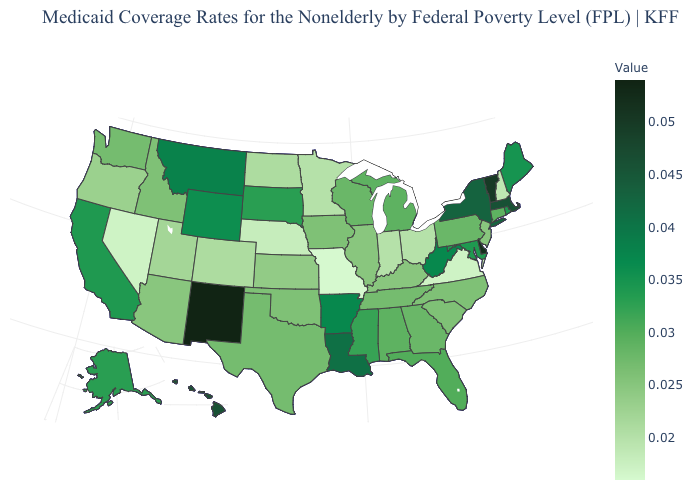Among the states that border Illinois , which have the lowest value?
Keep it brief. Missouri. Among the states that border Florida , does Alabama have the lowest value?
Answer briefly. No. Does Nevada have the lowest value in the West?
Short answer required. Yes. Does Missouri have the highest value in the USA?
Be succinct. No. Does Washington have a higher value than Ohio?
Write a very short answer. Yes. Does Missouri have the lowest value in the USA?
Answer briefly. Yes. Does Montana have a lower value than Tennessee?
Concise answer only. No. 